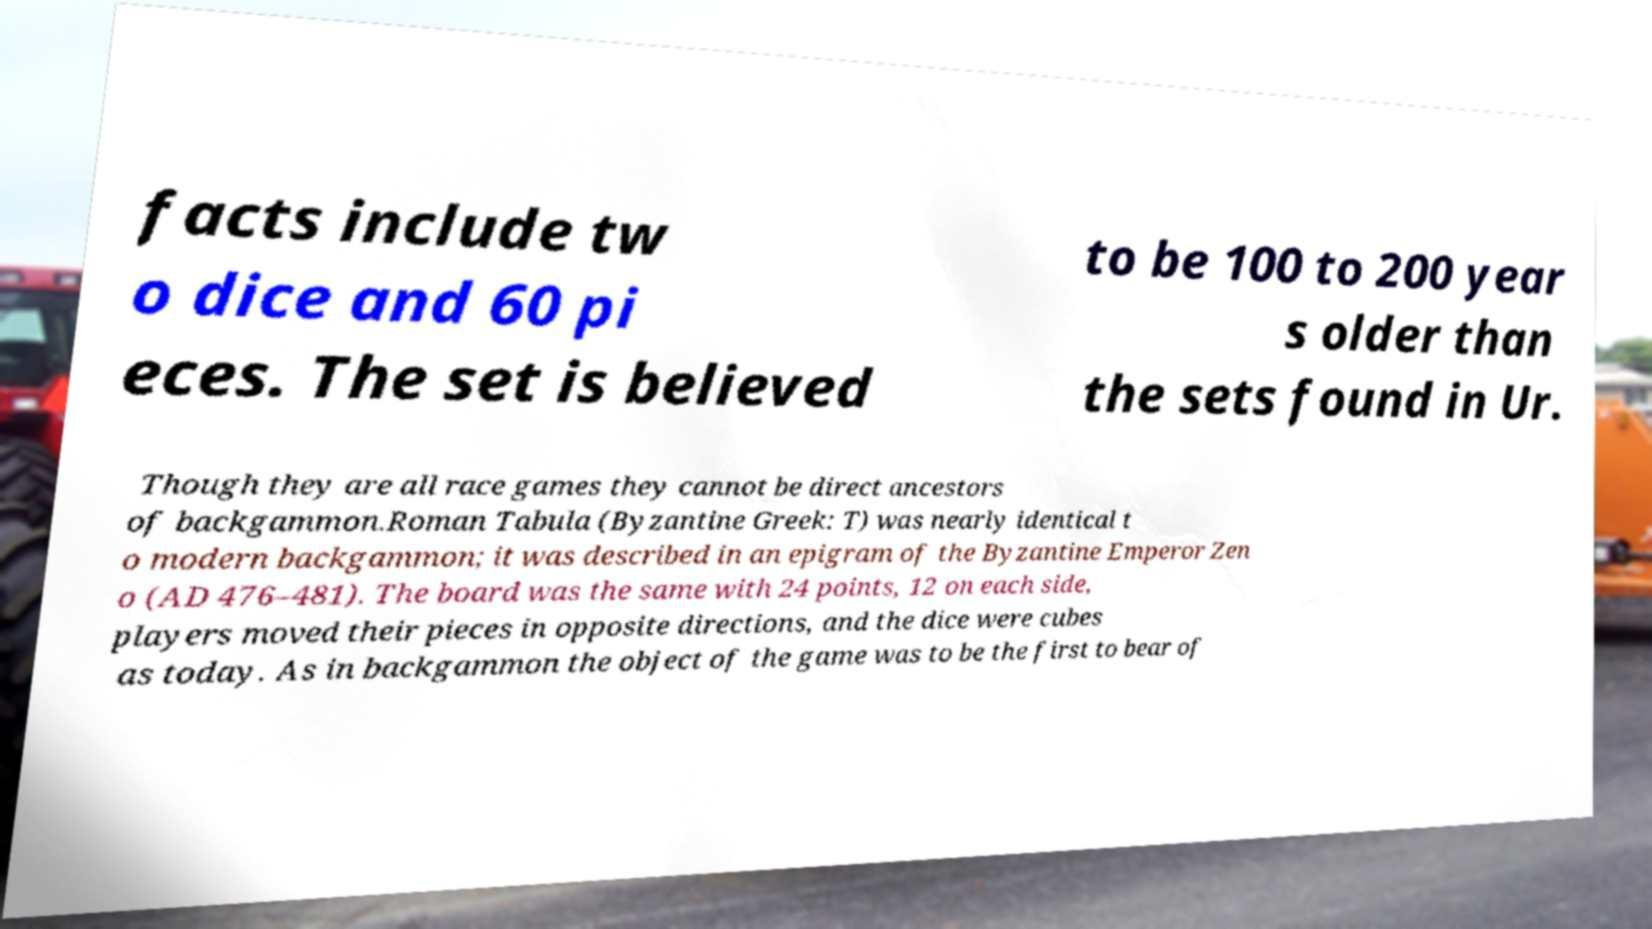What messages or text are displayed in this image? I need them in a readable, typed format. facts include tw o dice and 60 pi eces. The set is believed to be 100 to 200 year s older than the sets found in Ur. Though they are all race games they cannot be direct ancestors of backgammon.Roman Tabula (Byzantine Greek: T) was nearly identical t o modern backgammon; it was described in an epigram of the Byzantine Emperor Zen o (AD 476–481). The board was the same with 24 points, 12 on each side, players moved their pieces in opposite directions, and the dice were cubes as today. As in backgammon the object of the game was to be the first to bear of 